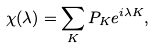Convert formula to latex. <formula><loc_0><loc_0><loc_500><loc_500>\chi ( \lambda ) = \sum _ { K } P _ { K } e ^ { i \lambda K } ,</formula> 